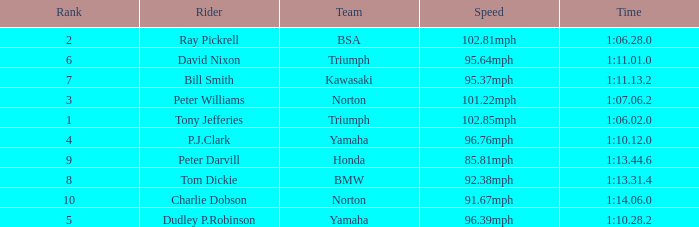At 96.76mph speed, what is the Time? 1:10.12.0. 